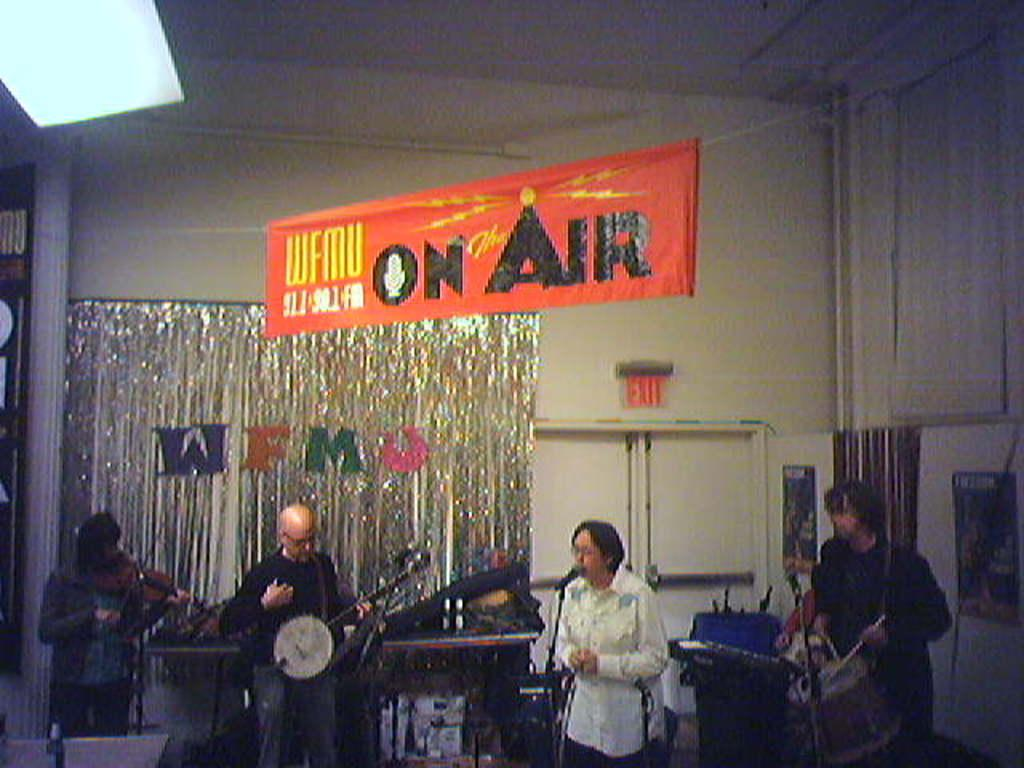What are the people in the image doing? The people in the image are standing and holding musical instruments. What objects are present in the image that might be used for amplifying sound? There are microphones (mics) in the image. What type of structures can be seen in the image that might be used for holding instruments or equipment? There are stands in the image. What architectural features are visible in the image? There are doors in the image. What color is the wall in the background of the image? There is a white wall in the image. What additional decorative element can be seen in the image? There is an orange banner in the image. What type of locket is hanging from the orange banner in the image? There is no locket present in the image, as the orange banner is a decorative element and not a piece of jewelry. 